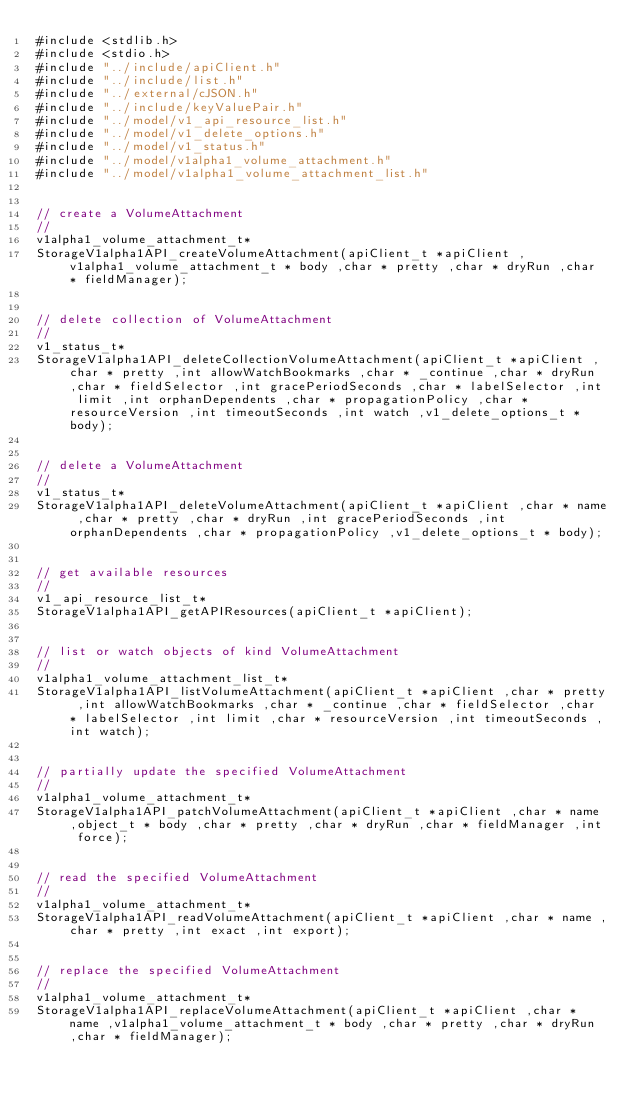<code> <loc_0><loc_0><loc_500><loc_500><_C_>#include <stdlib.h>
#include <stdio.h>
#include "../include/apiClient.h"
#include "../include/list.h"
#include "../external/cJSON.h"
#include "../include/keyValuePair.h"
#include "../model/v1_api_resource_list.h"
#include "../model/v1_delete_options.h"
#include "../model/v1_status.h"
#include "../model/v1alpha1_volume_attachment.h"
#include "../model/v1alpha1_volume_attachment_list.h"


// create a VolumeAttachment
//
v1alpha1_volume_attachment_t*
StorageV1alpha1API_createVolumeAttachment(apiClient_t *apiClient ,v1alpha1_volume_attachment_t * body ,char * pretty ,char * dryRun ,char * fieldManager);


// delete collection of VolumeAttachment
//
v1_status_t*
StorageV1alpha1API_deleteCollectionVolumeAttachment(apiClient_t *apiClient ,char * pretty ,int allowWatchBookmarks ,char * _continue ,char * dryRun ,char * fieldSelector ,int gracePeriodSeconds ,char * labelSelector ,int limit ,int orphanDependents ,char * propagationPolicy ,char * resourceVersion ,int timeoutSeconds ,int watch ,v1_delete_options_t * body);


// delete a VolumeAttachment
//
v1_status_t*
StorageV1alpha1API_deleteVolumeAttachment(apiClient_t *apiClient ,char * name ,char * pretty ,char * dryRun ,int gracePeriodSeconds ,int orphanDependents ,char * propagationPolicy ,v1_delete_options_t * body);


// get available resources
//
v1_api_resource_list_t*
StorageV1alpha1API_getAPIResources(apiClient_t *apiClient);


// list or watch objects of kind VolumeAttachment
//
v1alpha1_volume_attachment_list_t*
StorageV1alpha1API_listVolumeAttachment(apiClient_t *apiClient ,char * pretty ,int allowWatchBookmarks ,char * _continue ,char * fieldSelector ,char * labelSelector ,int limit ,char * resourceVersion ,int timeoutSeconds ,int watch);


// partially update the specified VolumeAttachment
//
v1alpha1_volume_attachment_t*
StorageV1alpha1API_patchVolumeAttachment(apiClient_t *apiClient ,char * name ,object_t * body ,char * pretty ,char * dryRun ,char * fieldManager ,int force);


// read the specified VolumeAttachment
//
v1alpha1_volume_attachment_t*
StorageV1alpha1API_readVolumeAttachment(apiClient_t *apiClient ,char * name ,char * pretty ,int exact ,int export);


// replace the specified VolumeAttachment
//
v1alpha1_volume_attachment_t*
StorageV1alpha1API_replaceVolumeAttachment(apiClient_t *apiClient ,char * name ,v1alpha1_volume_attachment_t * body ,char * pretty ,char * dryRun ,char * fieldManager);


</code> 